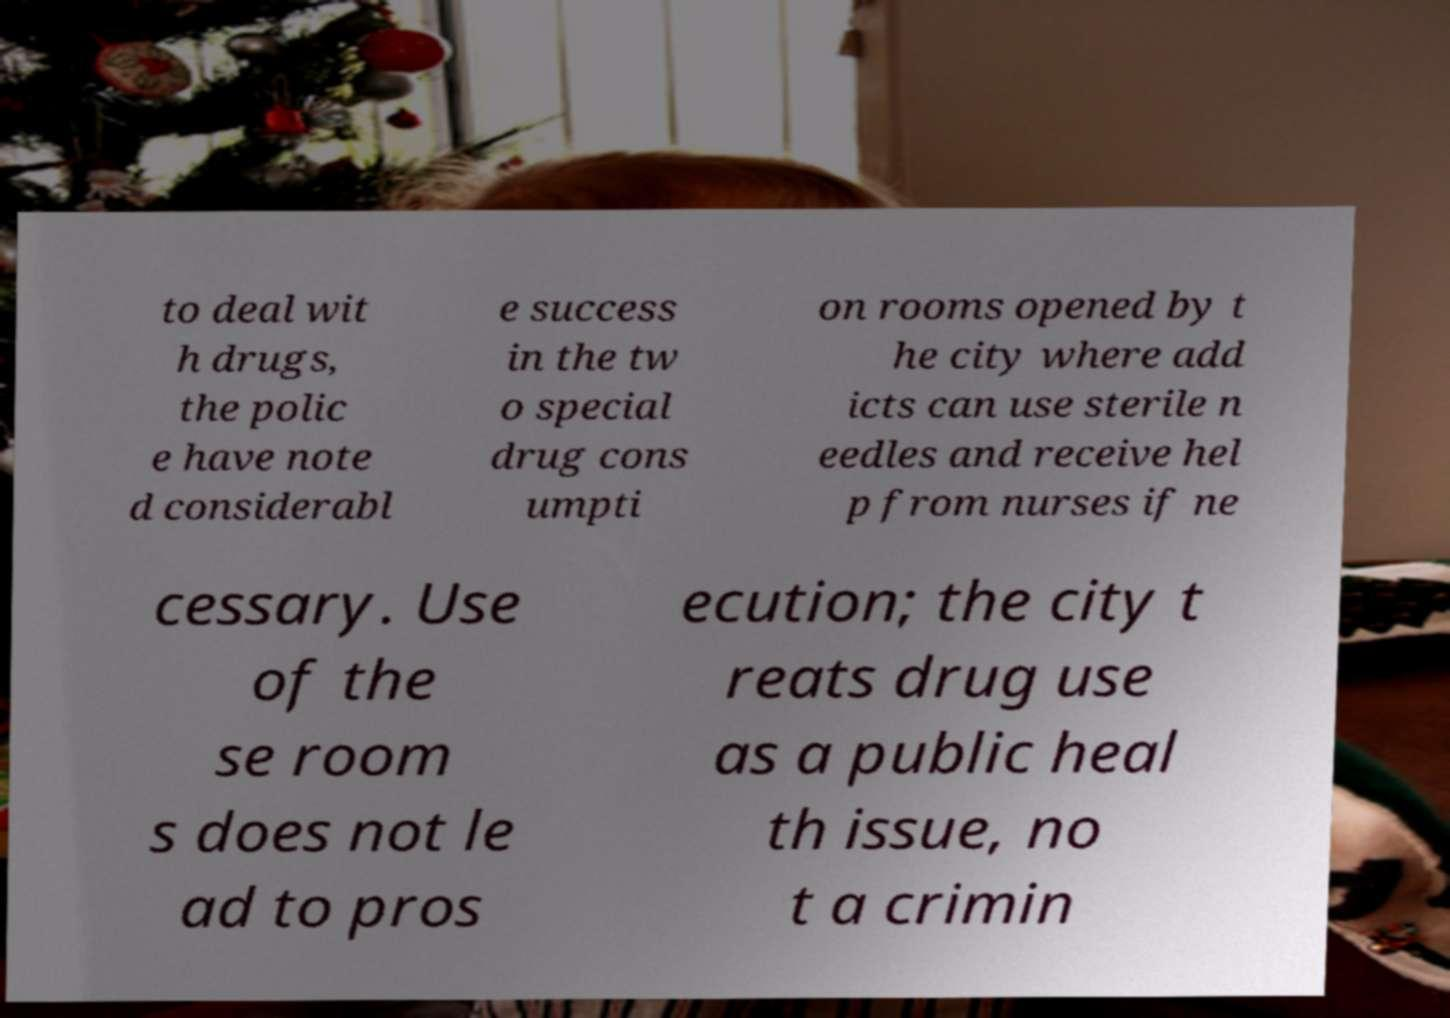Could you extract and type out the text from this image? to deal wit h drugs, the polic e have note d considerabl e success in the tw o special drug cons umpti on rooms opened by t he city where add icts can use sterile n eedles and receive hel p from nurses if ne cessary. Use of the se room s does not le ad to pros ecution; the city t reats drug use as a public heal th issue, no t a crimin 